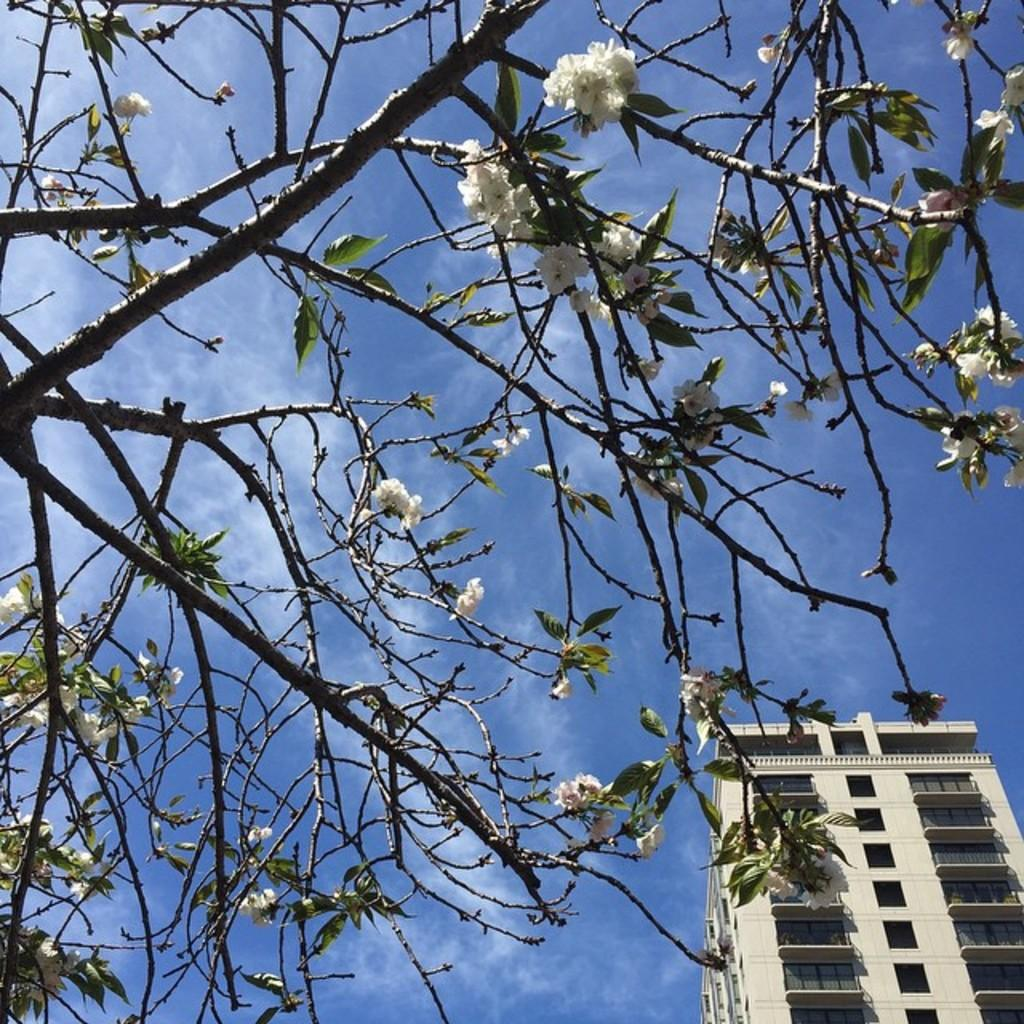What type of tree is present in the image? There is a tree with white flowers in the image. What can be seen in the background of the image? There is a building visible in the background of the image. What type of liquid is being used to power the tree in the image? There is no liquid or power source mentioned in the image; it is a tree with white flowers. 